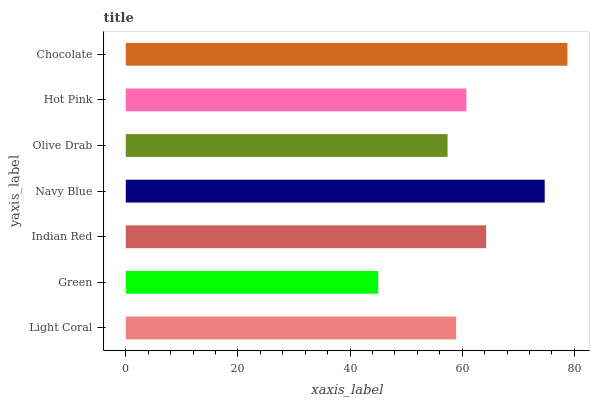Is Green the minimum?
Answer yes or no. Yes. Is Chocolate the maximum?
Answer yes or no. Yes. Is Indian Red the minimum?
Answer yes or no. No. Is Indian Red the maximum?
Answer yes or no. No. Is Indian Red greater than Green?
Answer yes or no. Yes. Is Green less than Indian Red?
Answer yes or no. Yes. Is Green greater than Indian Red?
Answer yes or no. No. Is Indian Red less than Green?
Answer yes or no. No. Is Hot Pink the high median?
Answer yes or no. Yes. Is Hot Pink the low median?
Answer yes or no. Yes. Is Chocolate the high median?
Answer yes or no. No. Is Navy Blue the low median?
Answer yes or no. No. 